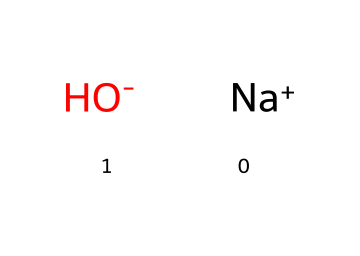What is the central ion in this compound? The SMILES representation indicates that sodium hydroxide consists of sodium (Na) as the central ion, which is denoted by [Na+].
Answer: sodium How many atoms are present in this chemical? In the SMILES representation, there are two components: sodium (Na) and hydroxide (OH), which together represent three atoms (1 Na + 1 O + 1 H).
Answer: three What charge does the hydroxide ion carry? The SMILES notation shows [OH-], indicating that the hydroxide ion has a negative charge.
Answer: negative What is the primary use of sodium hydroxide? Sodium hydroxide is primarily used as an industrial cleaning agent and in the production of various chemicals.
Answer: cleaning agent What type of chemical is sodium hydroxide classified as? Considering its chemical structure and properties, sodium hydroxide is classified as a strong base because it fully dissociates in water.
Answer: strong base How does the presence of sodium ion affect the solubility of sodium hydroxide? Sodium ion increases the solubility of sodium hydroxide in water, as it stabilizes the dissociated hydroxide ions in solution.
Answer: increases solubility What happens to sodium hydroxide in water? When sodium hydroxide is dissolved in water, it dissociates into sodium ions and hydroxide ions, resulting in an alkaline solution.
Answer: dissociates 